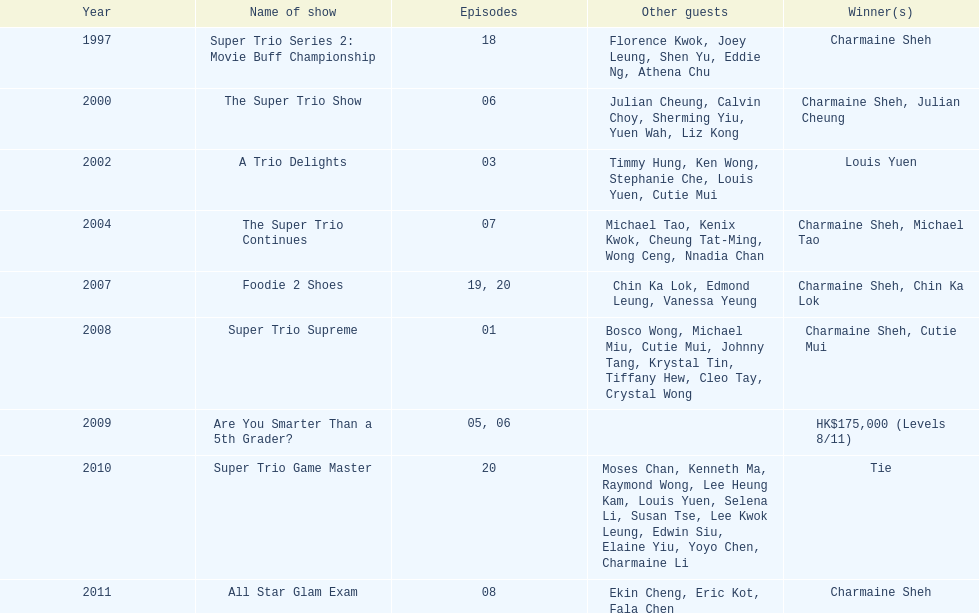How many of shows had at least 5 episodes? 7. 